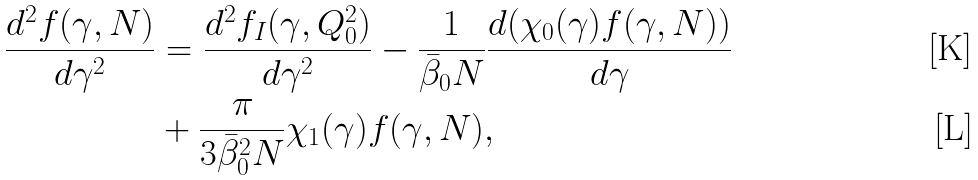<formula> <loc_0><loc_0><loc_500><loc_500>\frac { d ^ { 2 } f ( \gamma , N ) } { d \gamma ^ { 2 } } & = \frac { d ^ { 2 } f _ { I } ( \gamma , Q _ { 0 } ^ { 2 } ) } { d \gamma ^ { 2 } } - \frac { 1 } { \bar { \beta } _ { 0 } N } \frac { d ( \chi _ { 0 } ( \gamma ) f ( \gamma , N ) ) } { d \gamma } \\ & + \frac { \pi } { 3 \bar { \beta } _ { 0 } ^ { 2 } N } \chi _ { 1 } ( \gamma ) f ( \gamma , N ) ,</formula> 